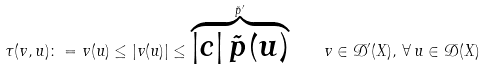Convert formula to latex. <formula><loc_0><loc_0><loc_500><loc_500>\tau ( v , u ) \colon = v ( u ) \leq | v ( u ) | \leq \overbrace { | c | \, \tilde { p } ( u ) } ^ { \tilde { p } ^ { \prime } } \quad v \in \mathcal { D } ^ { \prime } ( X ) , \, \forall \, u \in \mathcal { D } ( X )</formula> 